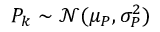Convert formula to latex. <formula><loc_0><loc_0><loc_500><loc_500>P _ { k } \sim \mathcal { N } ( \mu _ { P } , \sigma _ { P } ^ { 2 } )</formula> 